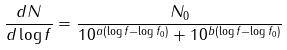Convert formula to latex. <formula><loc_0><loc_0><loc_500><loc_500>\frac { d N } { d \log f } = \frac { N _ { 0 } } { 1 0 ^ { a ( \log f - \log f _ { 0 } ) } + 1 0 ^ { b ( \log f - \log f _ { 0 } ) } }</formula> 